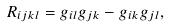Convert formula to latex. <formula><loc_0><loc_0><loc_500><loc_500>R _ { i j k l } = g _ { i l } g _ { j k } - g _ { i k } g _ { j l } ,</formula> 